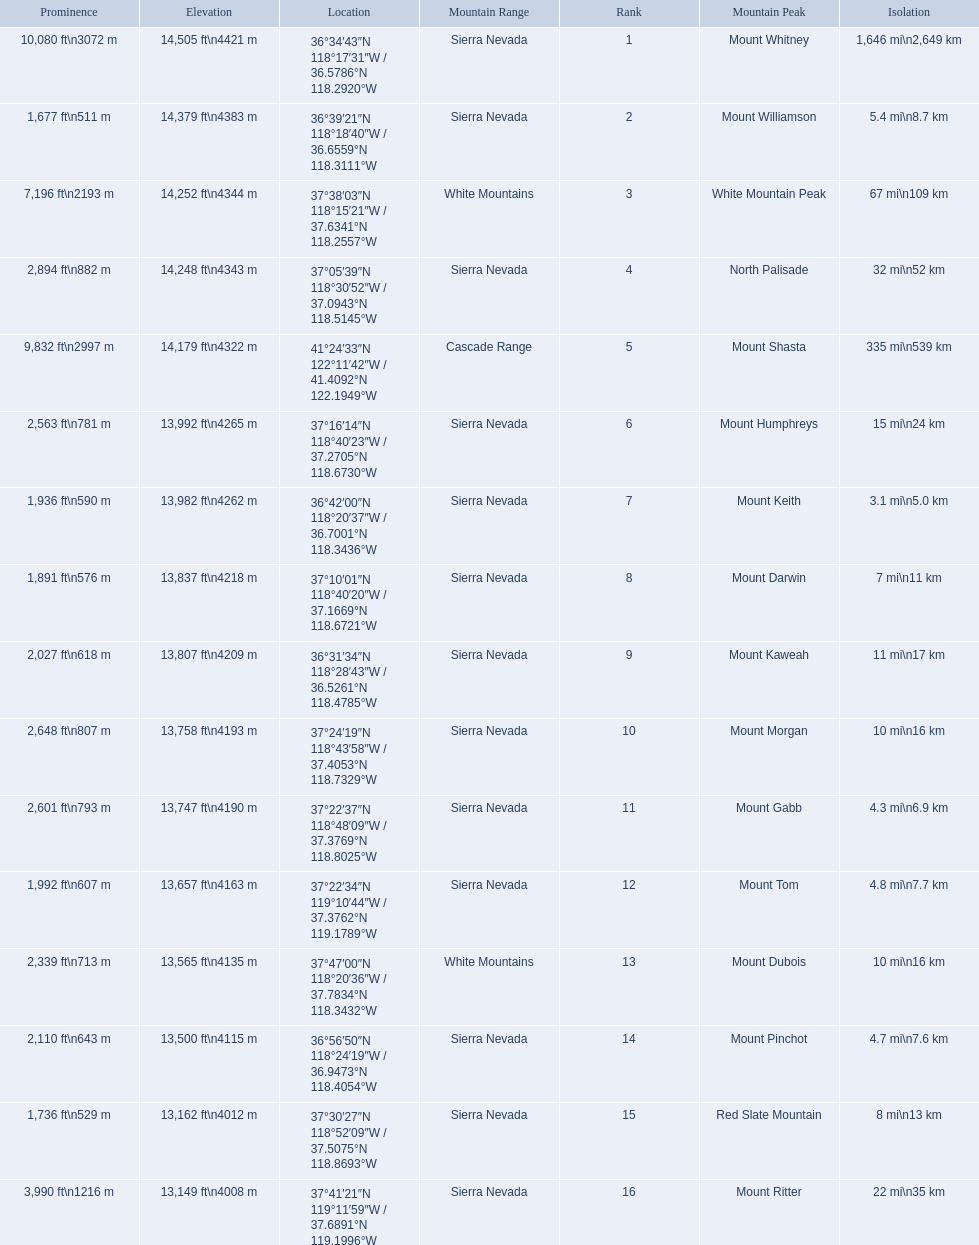Which mountain peaks are lower than 14,000 ft? Mount Humphreys, Mount Keith, Mount Darwin, Mount Kaweah, Mount Morgan, Mount Gabb, Mount Tom, Mount Dubois, Mount Pinchot, Red Slate Mountain, Mount Ritter. Are any of them below 13,500? if so, which ones? Red Slate Mountain, Mount Ritter. What's the lowest peak? 13,149 ft\n4008 m. Which one is that? Mount Ritter. 